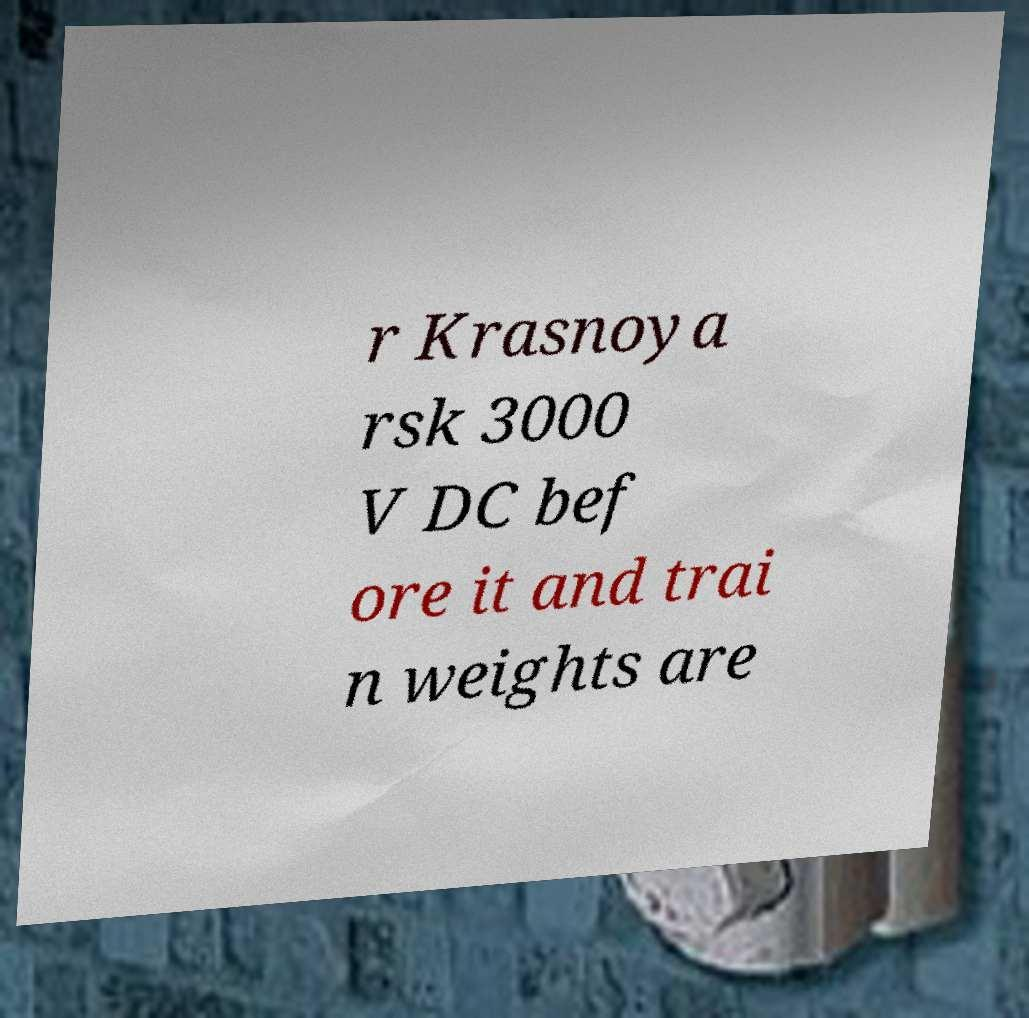Can you accurately transcribe the text from the provided image for me? r Krasnoya rsk 3000 V DC bef ore it and trai n weights are 